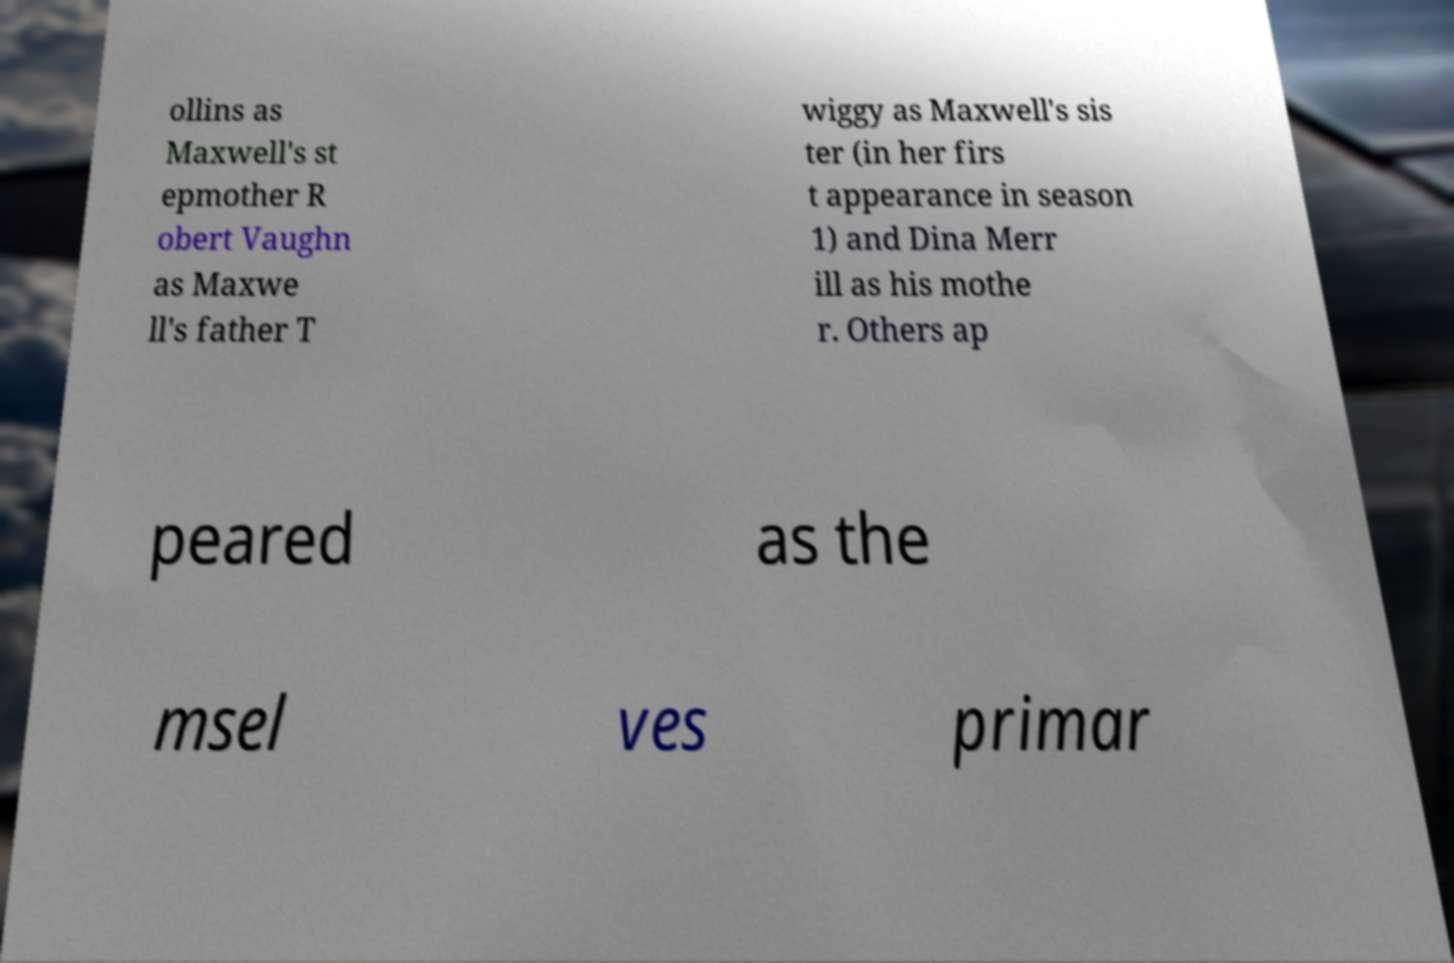Please identify and transcribe the text found in this image. ollins as Maxwell's st epmother R obert Vaughn as Maxwe ll's father T wiggy as Maxwell's sis ter (in her firs t appearance in season 1) and Dina Merr ill as his mothe r. Others ap peared as the msel ves primar 